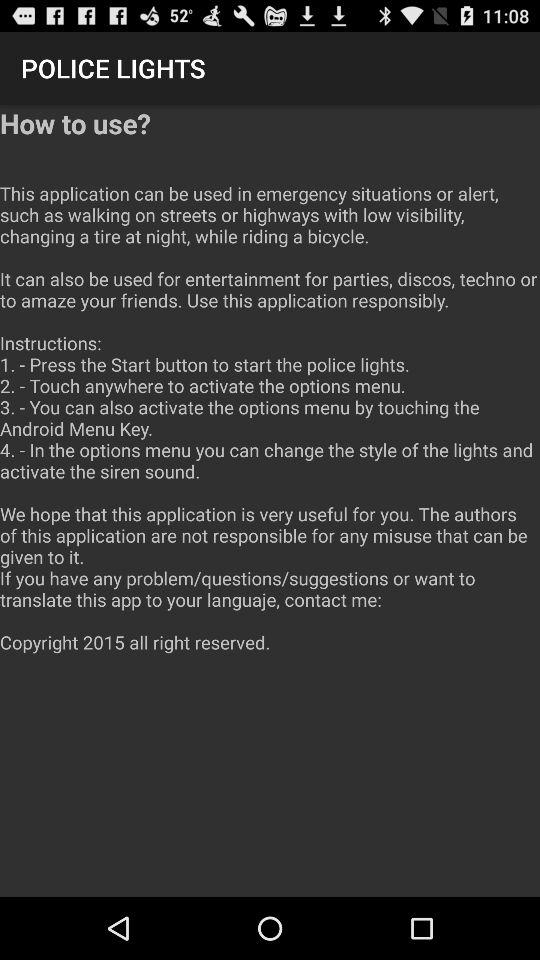How many steps are there in the instructions?
Answer the question using a single word or phrase. 4 